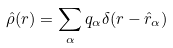<formula> <loc_0><loc_0><loc_500><loc_500>\hat { \rho } ( { r } ) = \sum _ { \alpha } q _ { \alpha } \delta ( { r } - \hat { r } _ { \alpha } )</formula> 